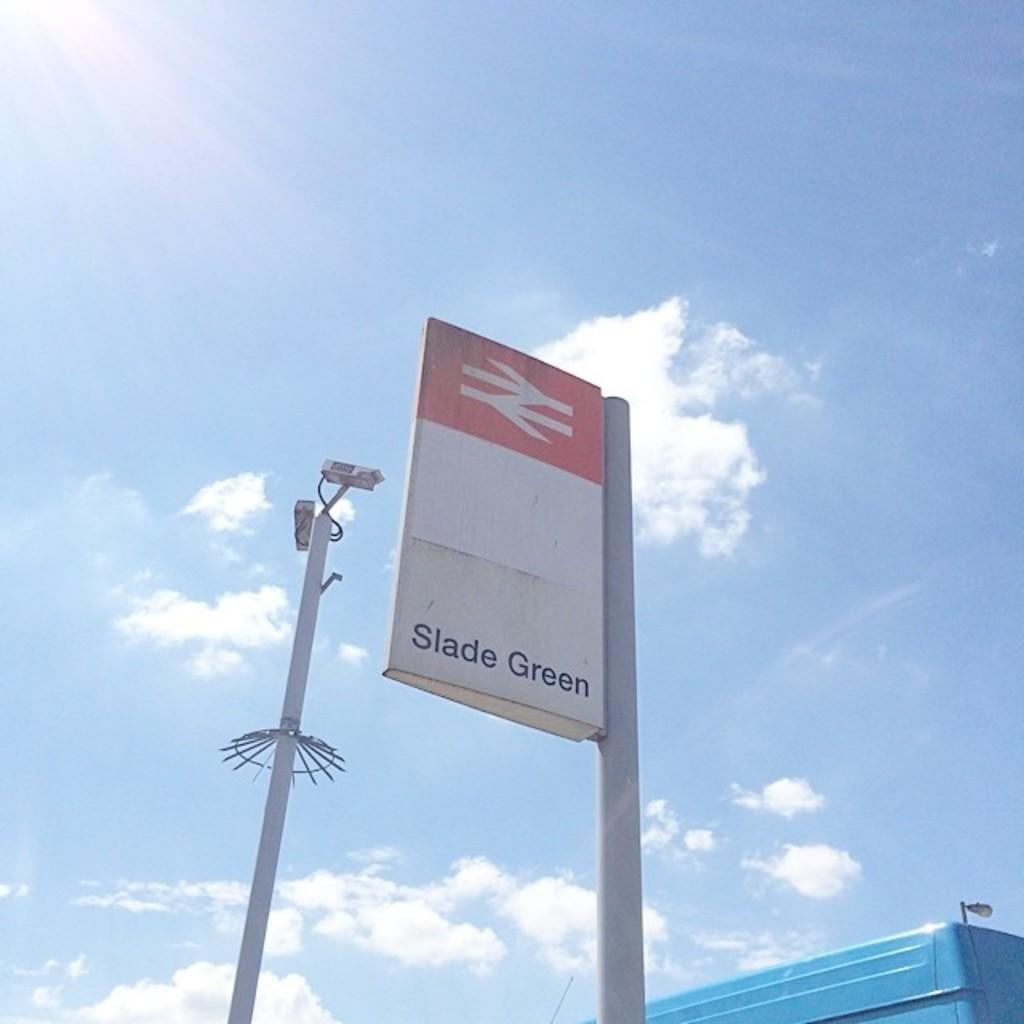<image>
Describe the image concisely. A sign on a pole that reads Slade Green. 